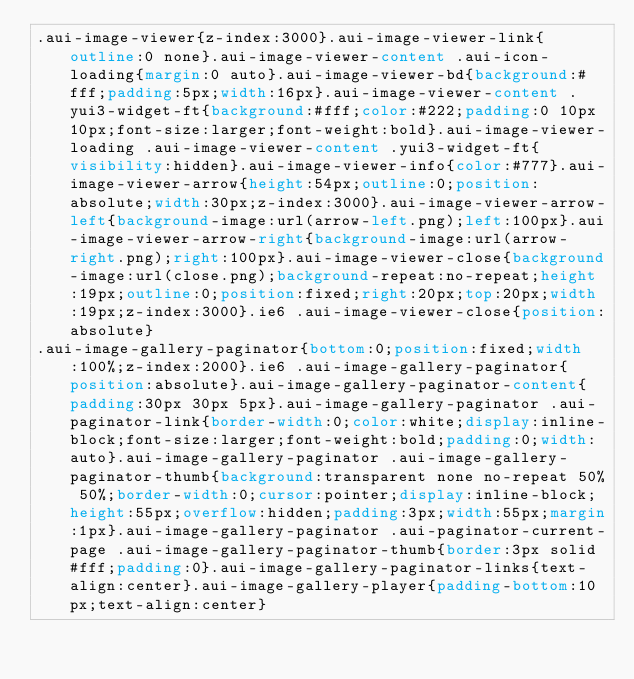Convert code to text. <code><loc_0><loc_0><loc_500><loc_500><_CSS_>.aui-image-viewer{z-index:3000}.aui-image-viewer-link{outline:0 none}.aui-image-viewer-content .aui-icon-loading{margin:0 auto}.aui-image-viewer-bd{background:#fff;padding:5px;width:16px}.aui-image-viewer-content .yui3-widget-ft{background:#fff;color:#222;padding:0 10px 10px;font-size:larger;font-weight:bold}.aui-image-viewer-loading .aui-image-viewer-content .yui3-widget-ft{visibility:hidden}.aui-image-viewer-info{color:#777}.aui-image-viewer-arrow{height:54px;outline:0;position:absolute;width:30px;z-index:3000}.aui-image-viewer-arrow-left{background-image:url(arrow-left.png);left:100px}.aui-image-viewer-arrow-right{background-image:url(arrow-right.png);right:100px}.aui-image-viewer-close{background-image:url(close.png);background-repeat:no-repeat;height:19px;outline:0;position:fixed;right:20px;top:20px;width:19px;z-index:3000}.ie6 .aui-image-viewer-close{position:absolute}
.aui-image-gallery-paginator{bottom:0;position:fixed;width:100%;z-index:2000}.ie6 .aui-image-gallery-paginator{position:absolute}.aui-image-gallery-paginator-content{padding:30px 30px 5px}.aui-image-gallery-paginator .aui-paginator-link{border-width:0;color:white;display:inline-block;font-size:larger;font-weight:bold;padding:0;width:auto}.aui-image-gallery-paginator .aui-image-gallery-paginator-thumb{background:transparent none no-repeat 50% 50%;border-width:0;cursor:pointer;display:inline-block;height:55px;overflow:hidden;padding:3px;width:55px;margin:1px}.aui-image-gallery-paginator .aui-paginator-current-page .aui-image-gallery-paginator-thumb{border:3px solid #fff;padding:0}.aui-image-gallery-paginator-links{text-align:center}.aui-image-gallery-player{padding-bottom:10px;text-align:center}
</code> 